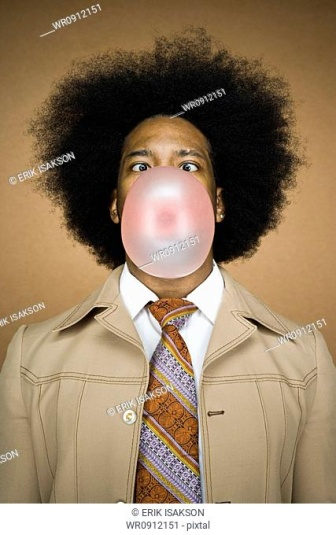Create a short dialogue where the person in the image is explaining their quirky tie choice to a curious colleague. Colleague: 'Hey, nice tie! What's the story behind it?'
Person: 'Thanks! I was feeling a bit nostalgic today and wanted to bring a bit of the 70s flair to the office. Plus, it's always fun to have a pop of color among all the usual grays and blacks.'
Colleague: 'It’s definitely eye-catching! Adds some personality to the outfit.'
Person: 'Exactly! And who says you can’t have a little fun with fashion? Especially on a Monday!' 